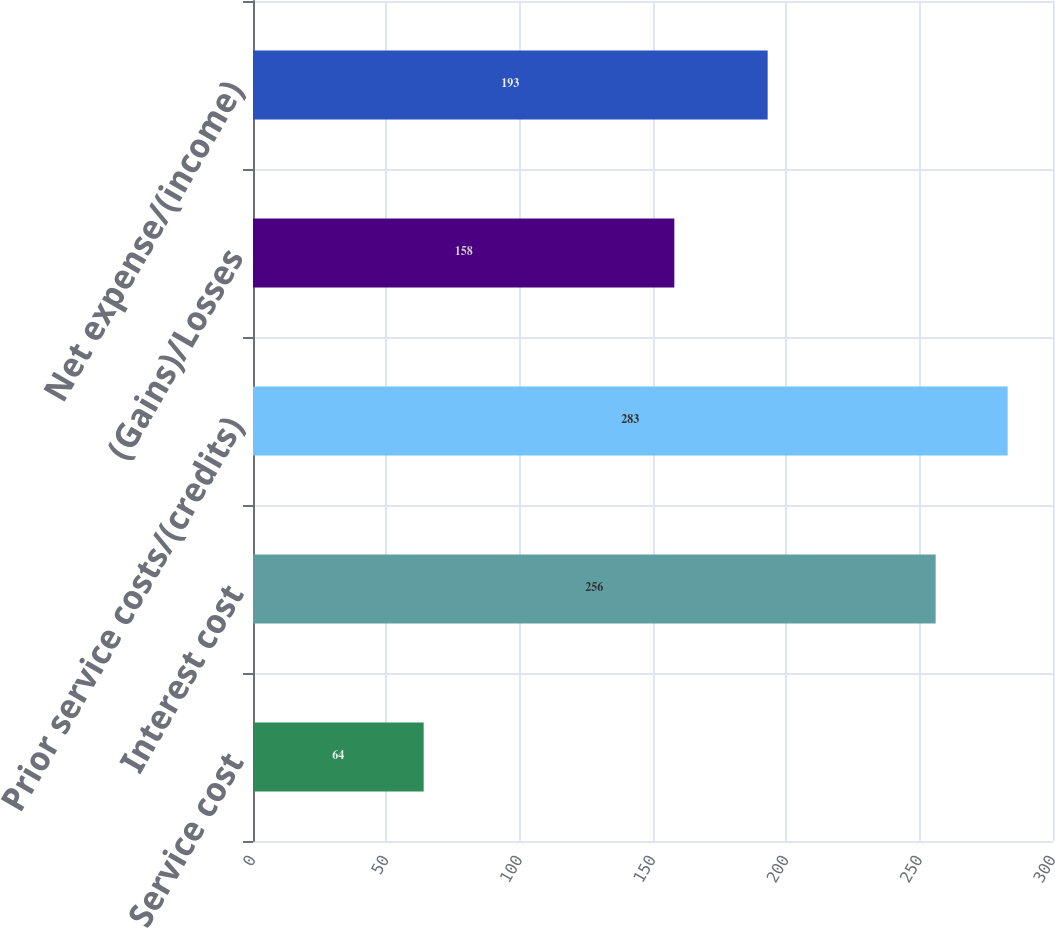Convert chart. <chart><loc_0><loc_0><loc_500><loc_500><bar_chart><fcel>Service cost<fcel>Interest cost<fcel>Prior service costs/(credits)<fcel>(Gains)/Losses<fcel>Net expense/(income)<nl><fcel>64<fcel>256<fcel>283<fcel>158<fcel>193<nl></chart> 